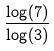Convert formula to latex. <formula><loc_0><loc_0><loc_500><loc_500>\frac { \log ( 7 ) } { \log ( 3 ) }</formula> 